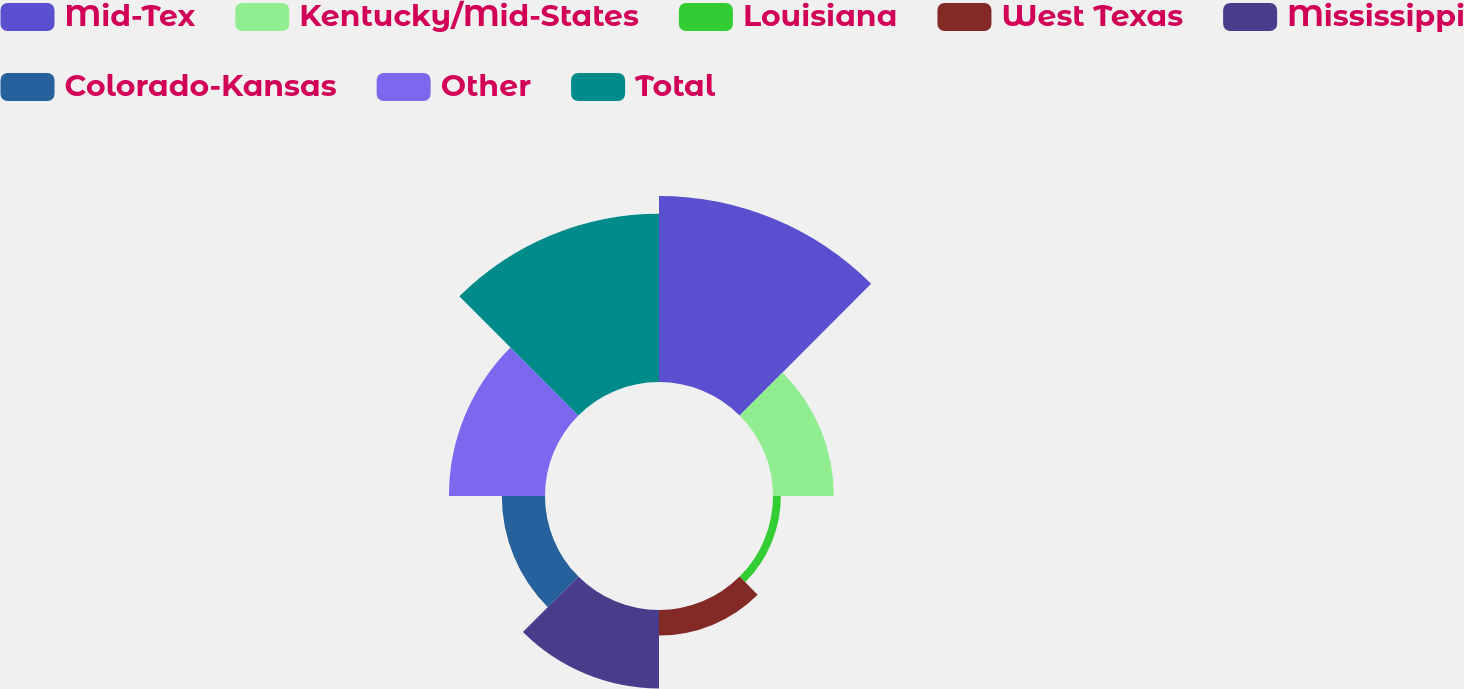Convert chart. <chart><loc_0><loc_0><loc_500><loc_500><pie_chart><fcel>Mid-Tex<fcel>Kentucky/Mid-States<fcel>Louisiana<fcel>West Texas<fcel>Mississippi<fcel>Colorado-Kansas<fcel>Other<fcel>Total<nl><fcel>27.92%<fcel>9.13%<fcel>1.18%<fcel>3.83%<fcel>11.77%<fcel>6.48%<fcel>14.42%<fcel>25.27%<nl></chart> 